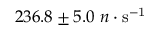<formula> <loc_0><loc_0><loc_500><loc_500>2 3 6 . 8 \pm 5 . 0 n \cdot s ^ { - 1 }</formula> 